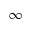Convert formula to latex. <formula><loc_0><loc_0><loc_500><loc_500>\infty</formula> 